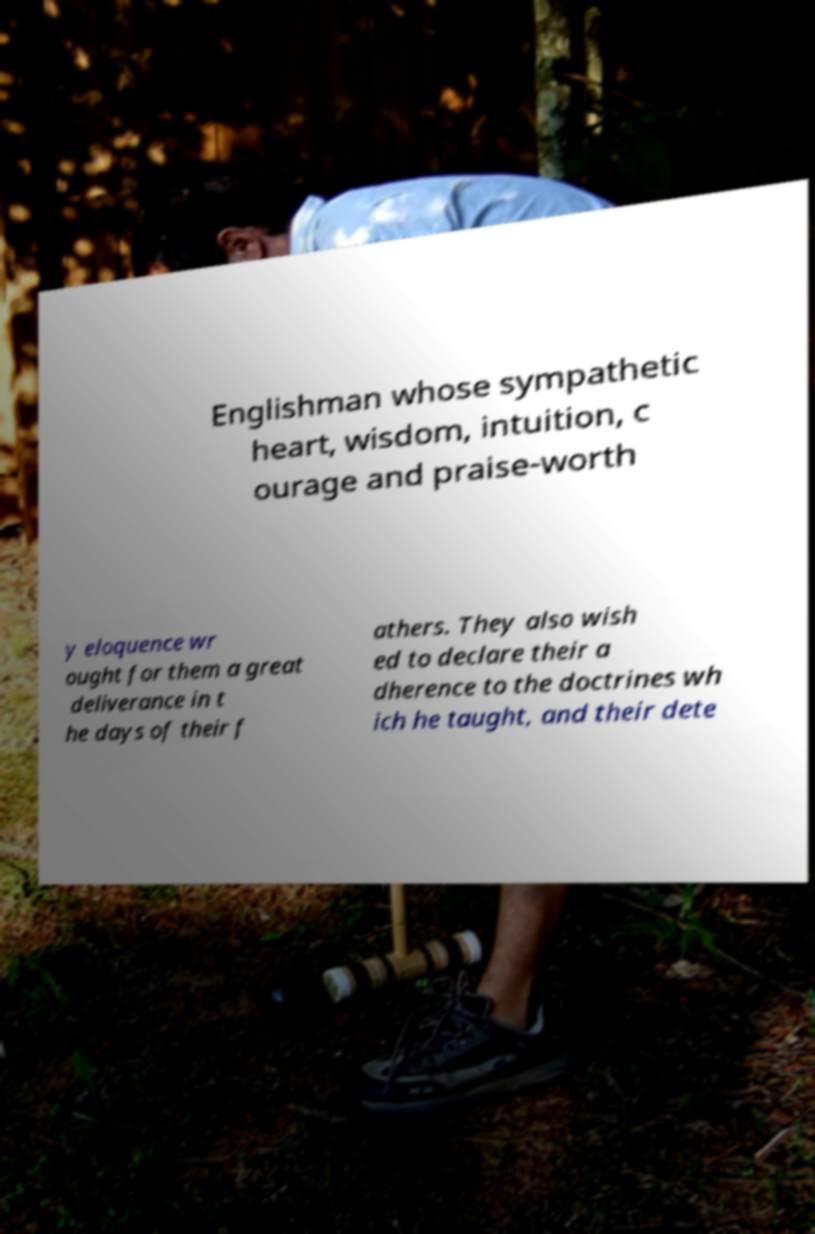There's text embedded in this image that I need extracted. Can you transcribe it verbatim? Englishman whose sympathetic heart, wisdom, intuition, c ourage and praise-worth y eloquence wr ought for them a great deliverance in t he days of their f athers. They also wish ed to declare their a dherence to the doctrines wh ich he taught, and their dete 